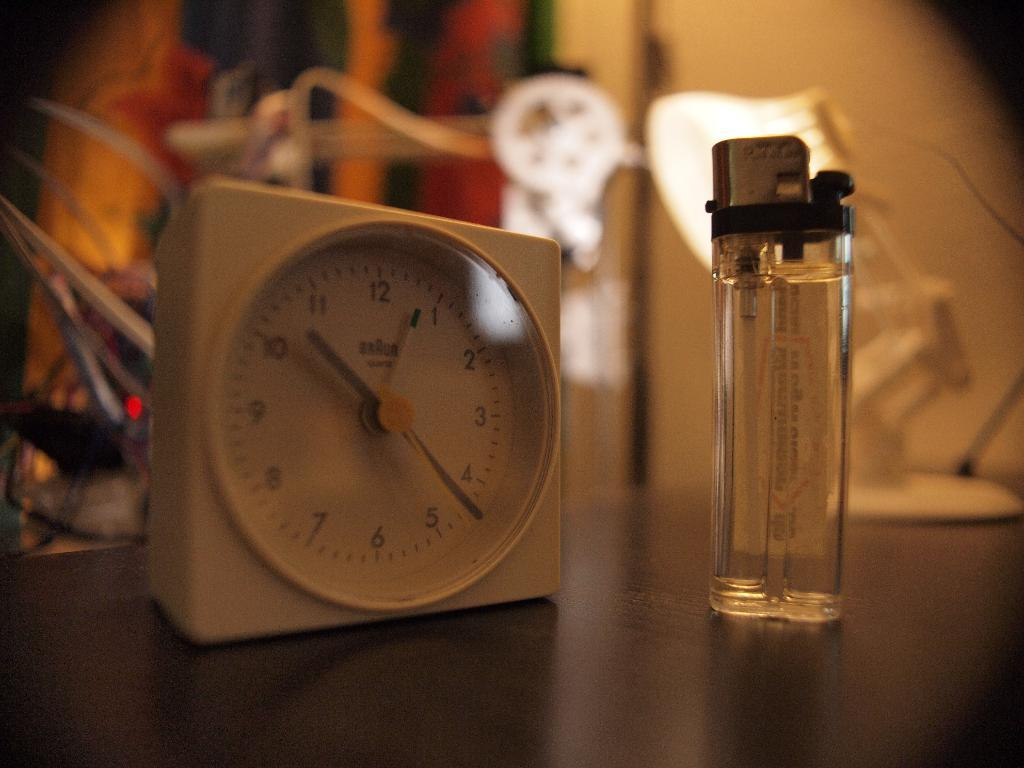<image>
Summarize the visual content of the image. A white Braun clock is placed next to a clear lighter. 